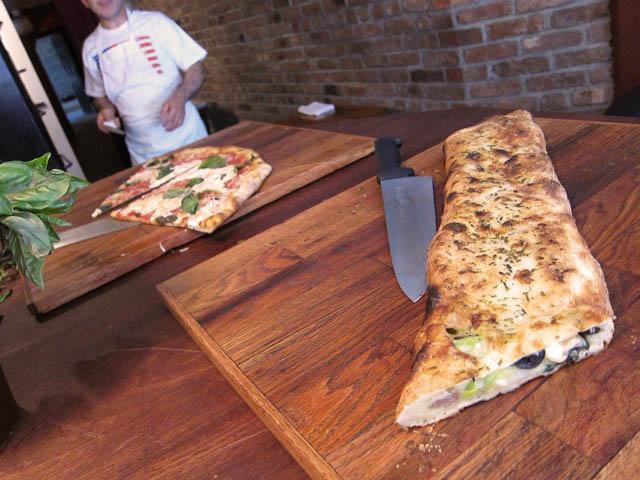How many pizzas can you see?
Give a very brief answer. 2. 